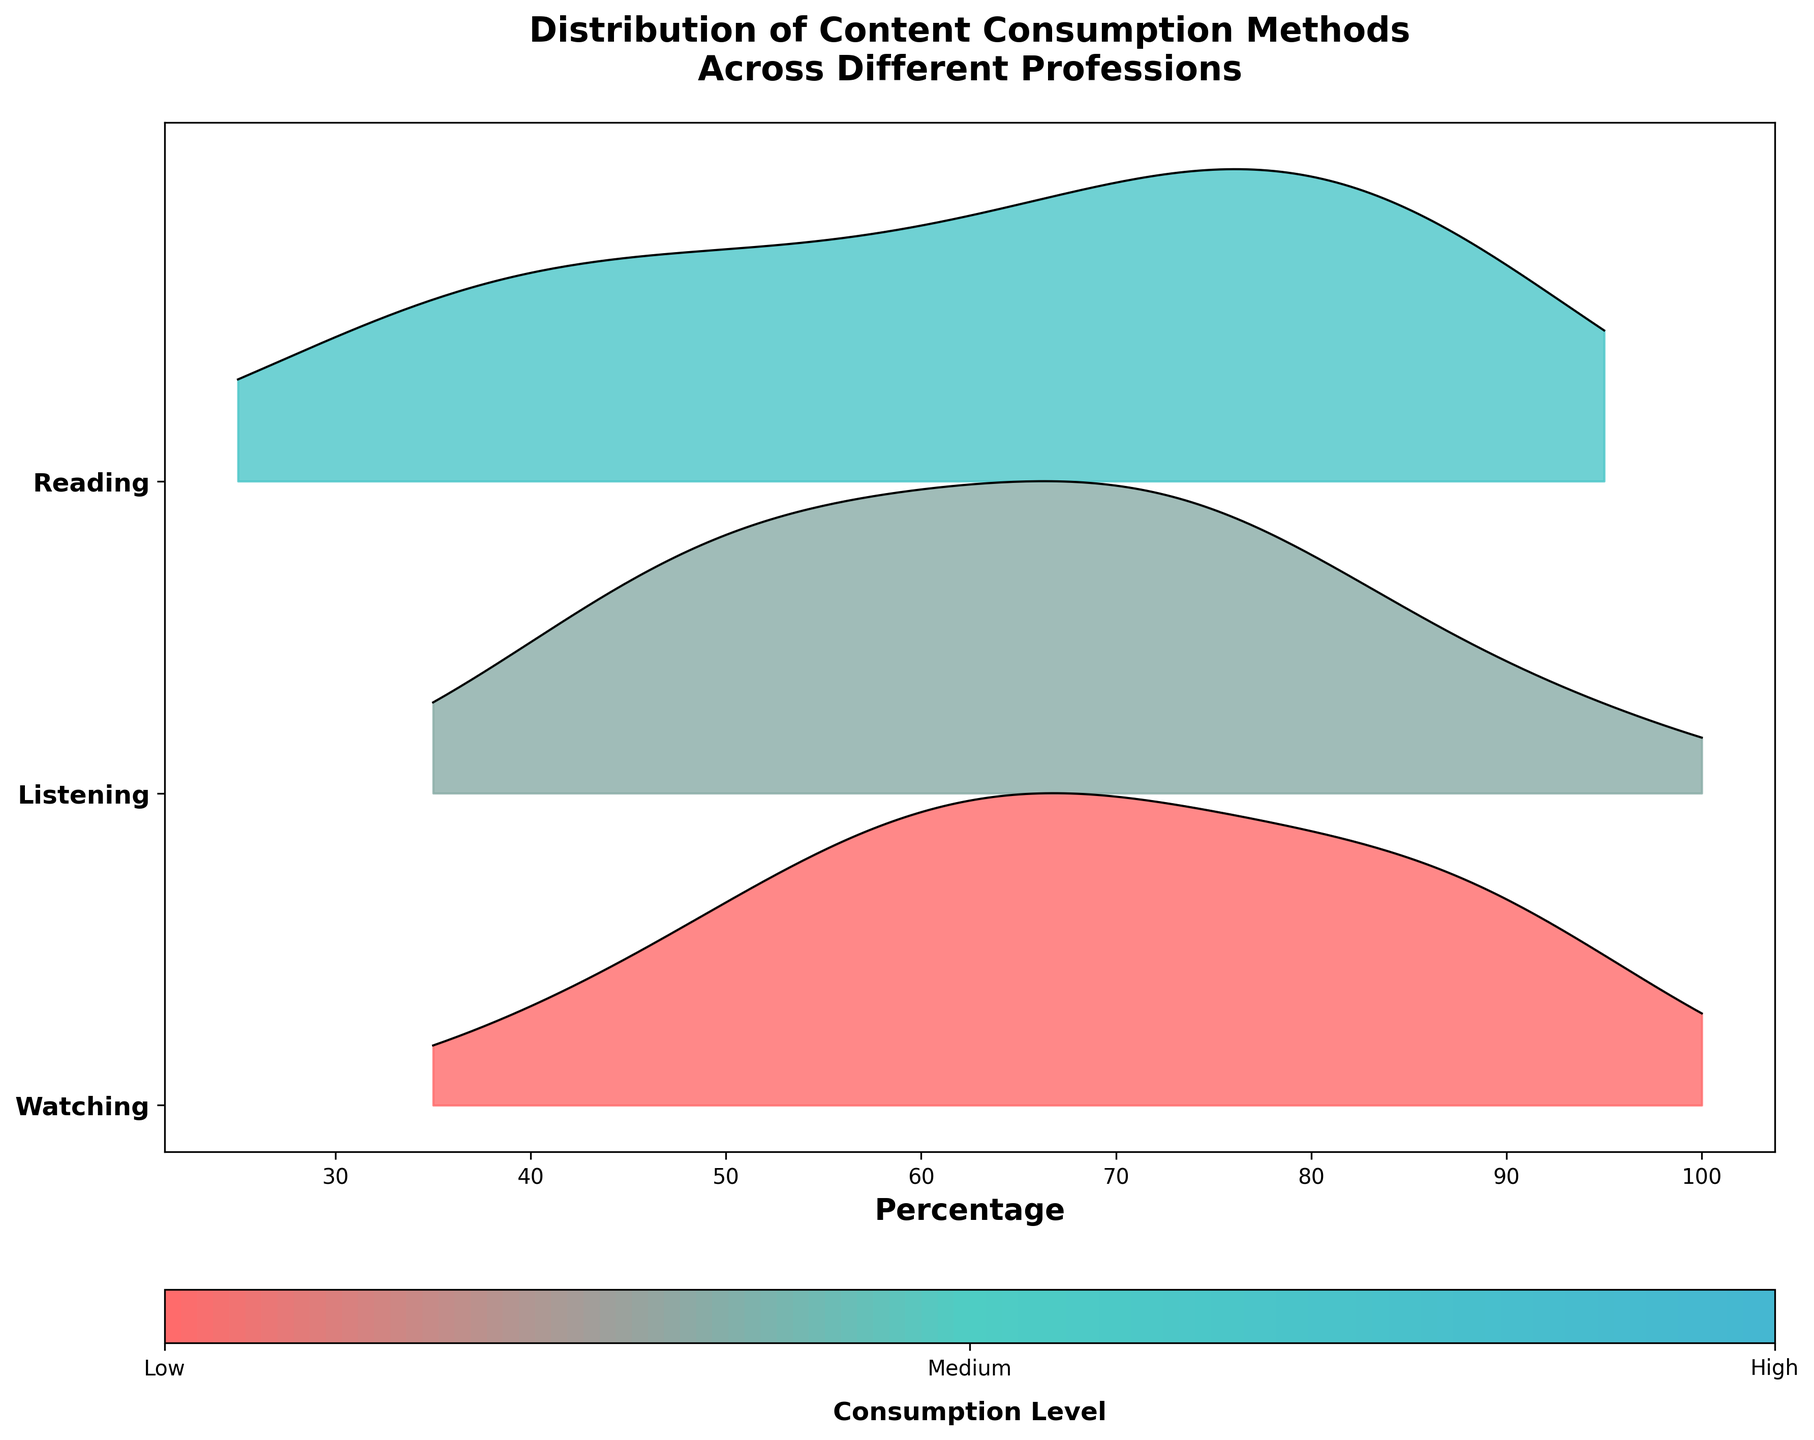How many professions are displayed in the plot? By counting the number of unique professions in the data, we can see that there are 15 different professions shown in the plot.
Answer: 15 Which profession appears to have the highest level of reading consumption? By examining the plotted data for reading consumption, the line that reaches the farthest to the right represents the profession with the highest consumption. Librarians have the highest reading consumption.
Answer: Librarians Which content consumption method do Chefs prefer the most? In the plot, by comparing the peaks of the distribution for Chefs, watching has the highest value among reading, listening, and watching.
Answer: Watching What is the general trend of listening consumption across professions? By looking at the patterns of the ridgeline plot for listening, it appears that listening consumption varies widely among different professions but is generally maximized for professions like Podcasters and minimized for Lawyers.
Answer: Varies widely Which two professions show a significant preference for watching content over reading and listening? By comparing the heights and positions of the distributions for watching, both Marketing Professionals and Graphic Designers exhibit higher peaks for watching compared to their reading and listening peaks.
Answer: Marketing Professionals, Graphic Designers Which content consumption method has the least variability across professions? Examining the spread and height of the ridgeline plots reveals that reading has the least variability in terms of distribution width and peak height across the range of professions.
Answer: Reading Do any of the professions have an equal preference for two different content consumption methods? By looking at the plots, HR Managers show an equal preference for reading and listening since their peaks are approximately the same height and position for both categories.
Answer: HR Managers Out of the three methods, which one does Podcasters prefer the least? By examining the distribution peaks for Podcasters, reading has the lowest peak, indicating it is the method they prefer the least.
Answer: Reading How does the content consumption for software developers differ from that of sales representatives? Software Developers show the highest consumption in reading, followed by listening, and the least in watching. In contrast, Sales Representatives have the highest consumption in listening, followed by watching, and the least in reading.
Answer: Software Developers prefer reading, Sales Representatives prefer listening 